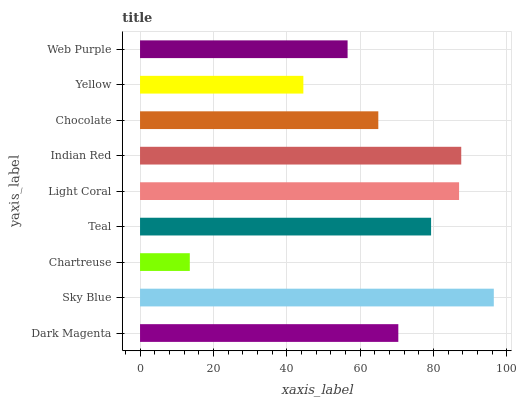Is Chartreuse the minimum?
Answer yes or no. Yes. Is Sky Blue the maximum?
Answer yes or no. Yes. Is Sky Blue the minimum?
Answer yes or no. No. Is Chartreuse the maximum?
Answer yes or no. No. Is Sky Blue greater than Chartreuse?
Answer yes or no. Yes. Is Chartreuse less than Sky Blue?
Answer yes or no. Yes. Is Chartreuse greater than Sky Blue?
Answer yes or no. No. Is Sky Blue less than Chartreuse?
Answer yes or no. No. Is Dark Magenta the high median?
Answer yes or no. Yes. Is Dark Magenta the low median?
Answer yes or no. Yes. Is Teal the high median?
Answer yes or no. No. Is Indian Red the low median?
Answer yes or no. No. 